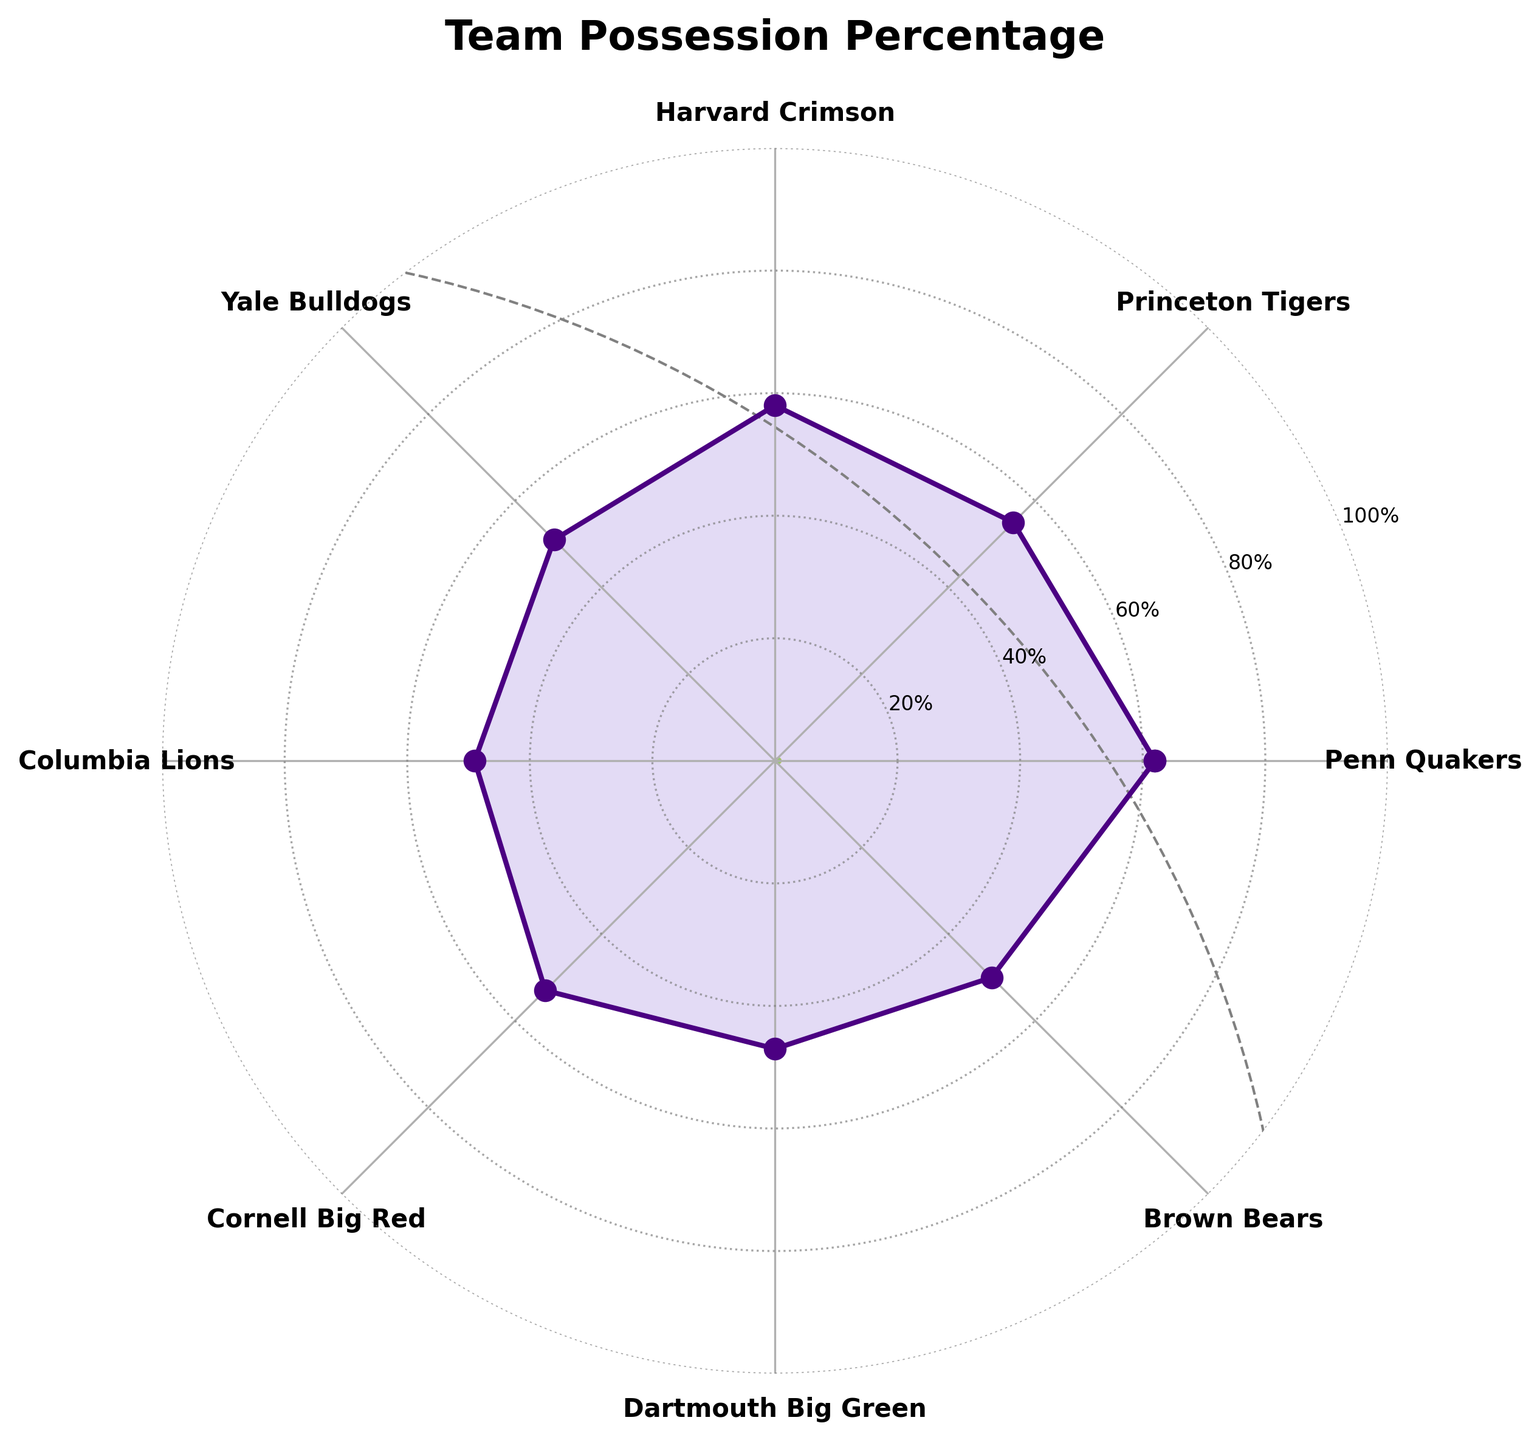What is the title of the figure? The title is usually displayed at the top of the chart and summarizes what the chart represents. In this case, it is located at the top center of the chart.
Answer: Team Possession Percentage How many teams are represented in the figure? The figure shows one data point for each team, equally spaced around the circular axis. By counting the labels around the polar plot, we can determine the number of teams.
Answer: 8 Which team has the highest possession percentage? Look for the team with the data point furthest from the center of the polar plot since this indicates a higher percentage.
Answer: Penn Quakers Which team has the lowest possession percentage? Look for the team with the data point closest to the center of the polar plot since this indicates a lower percentage.
Answer: Dartmouth Big Green What is the possession percentage of Harvard Crimson? Locate the label for Harvard Crimson on the polar plot and find the corresponding data point on the radial scale. Read the value indicated by this point.
Answer: 58% What is the range of the possession percentages shown in the figure? Identify the highest and lowest values on the polar plot and subtract the lowest value from the highest value.
Answer: 62% - 47% = 15% Which team has a possession percentage higher than both Princeton Tigers and Yale Bulldogs? First, identify the possession percentages of Princeton Tigers and Yale Bulldogs. Next, find which team has a higher percentage than both these values.
Answer: Penn Quakers What is the average possession percentage of the teams shown in the plot? Sum the possession percentages of all the teams and divide by the number of teams.
Answer: (62 + 55 + 58 + 51 + 49 + 53 + 47 + 50) / 8 = 53.125% Rank the teams from highest to lowest possession percentage. Order the teams by their possession percentage based on their distances from the center of the polar plot, from farthest to closest.
Answer: Penn Quakers, Harvard Crimson, Princeton Tigers, Cornell Big Red, Yale Bulldogs, Brown Bears, Columbia Lions, Dartmouth Big Green 